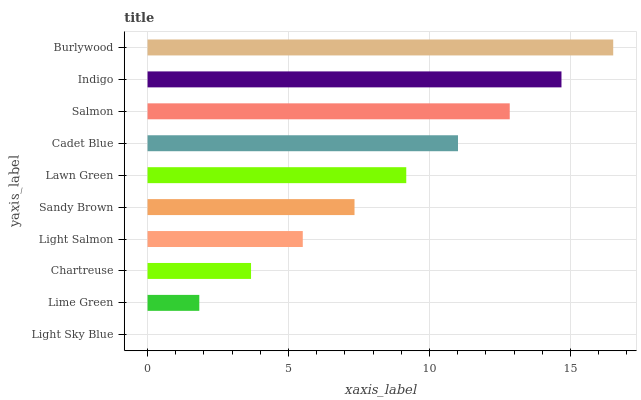Is Light Sky Blue the minimum?
Answer yes or no. Yes. Is Burlywood the maximum?
Answer yes or no. Yes. Is Lime Green the minimum?
Answer yes or no. No. Is Lime Green the maximum?
Answer yes or no. No. Is Lime Green greater than Light Sky Blue?
Answer yes or no. Yes. Is Light Sky Blue less than Lime Green?
Answer yes or no. Yes. Is Light Sky Blue greater than Lime Green?
Answer yes or no. No. Is Lime Green less than Light Sky Blue?
Answer yes or no. No. Is Lawn Green the high median?
Answer yes or no. Yes. Is Sandy Brown the low median?
Answer yes or no. Yes. Is Burlywood the high median?
Answer yes or no. No. Is Light Salmon the low median?
Answer yes or no. No. 